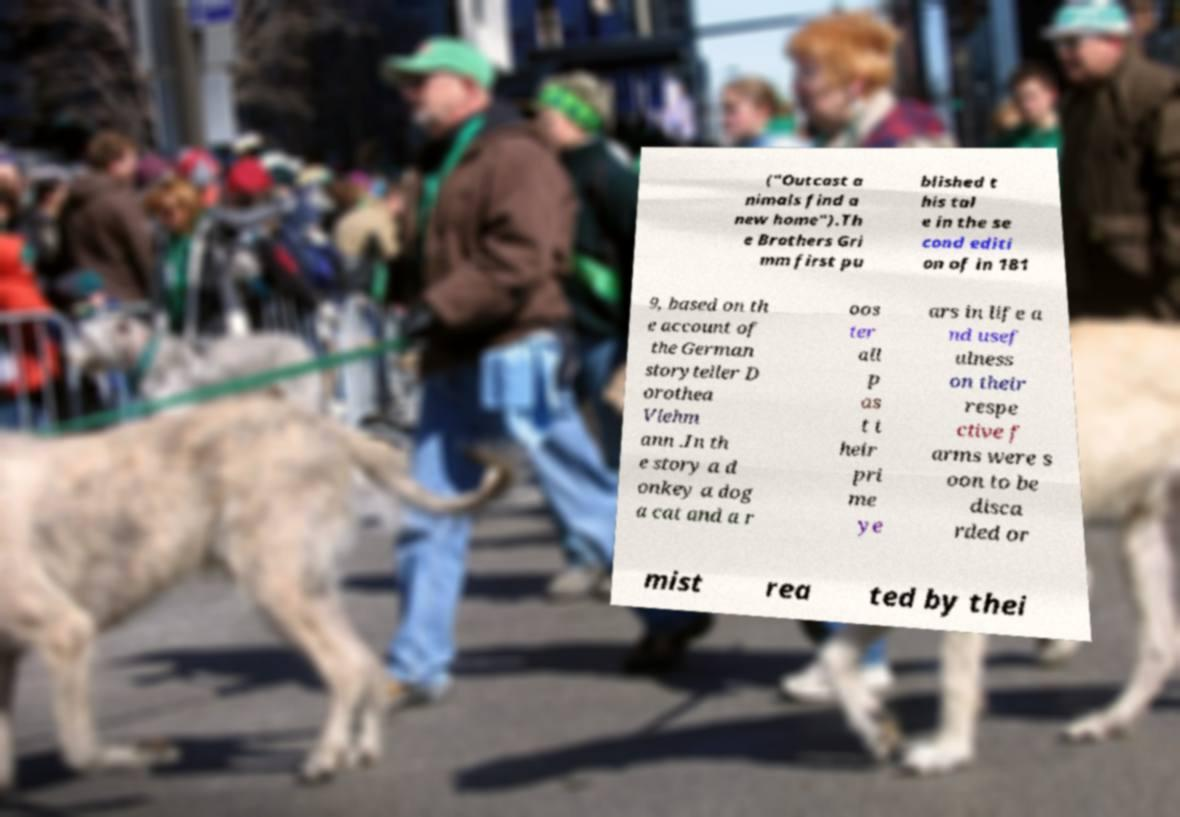There's text embedded in this image that I need extracted. Can you transcribe it verbatim? ("Outcast a nimals find a new home").Th e Brothers Gri mm first pu blished t his tal e in the se cond editi on of in 181 9, based on th e account of the German storyteller D orothea Viehm ann .In th e story a d onkey a dog a cat and a r oos ter all p as t t heir pri me ye ars in life a nd usef ulness on their respe ctive f arms were s oon to be disca rded or mist rea ted by thei 